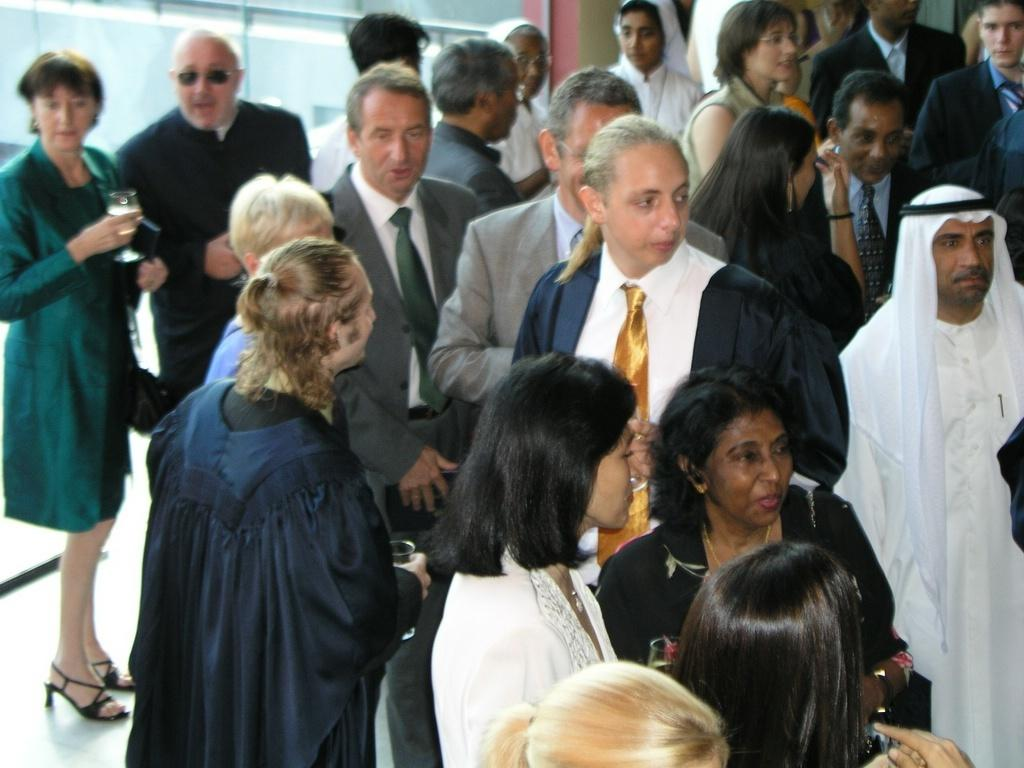How many people are present in the image? There are many people standing in the image. What are some of the people holding in their hands? There are a few people holding glasses in their hands. What type of produce is being displayed on the beds in the image? There are no beds or produce present in the image. 